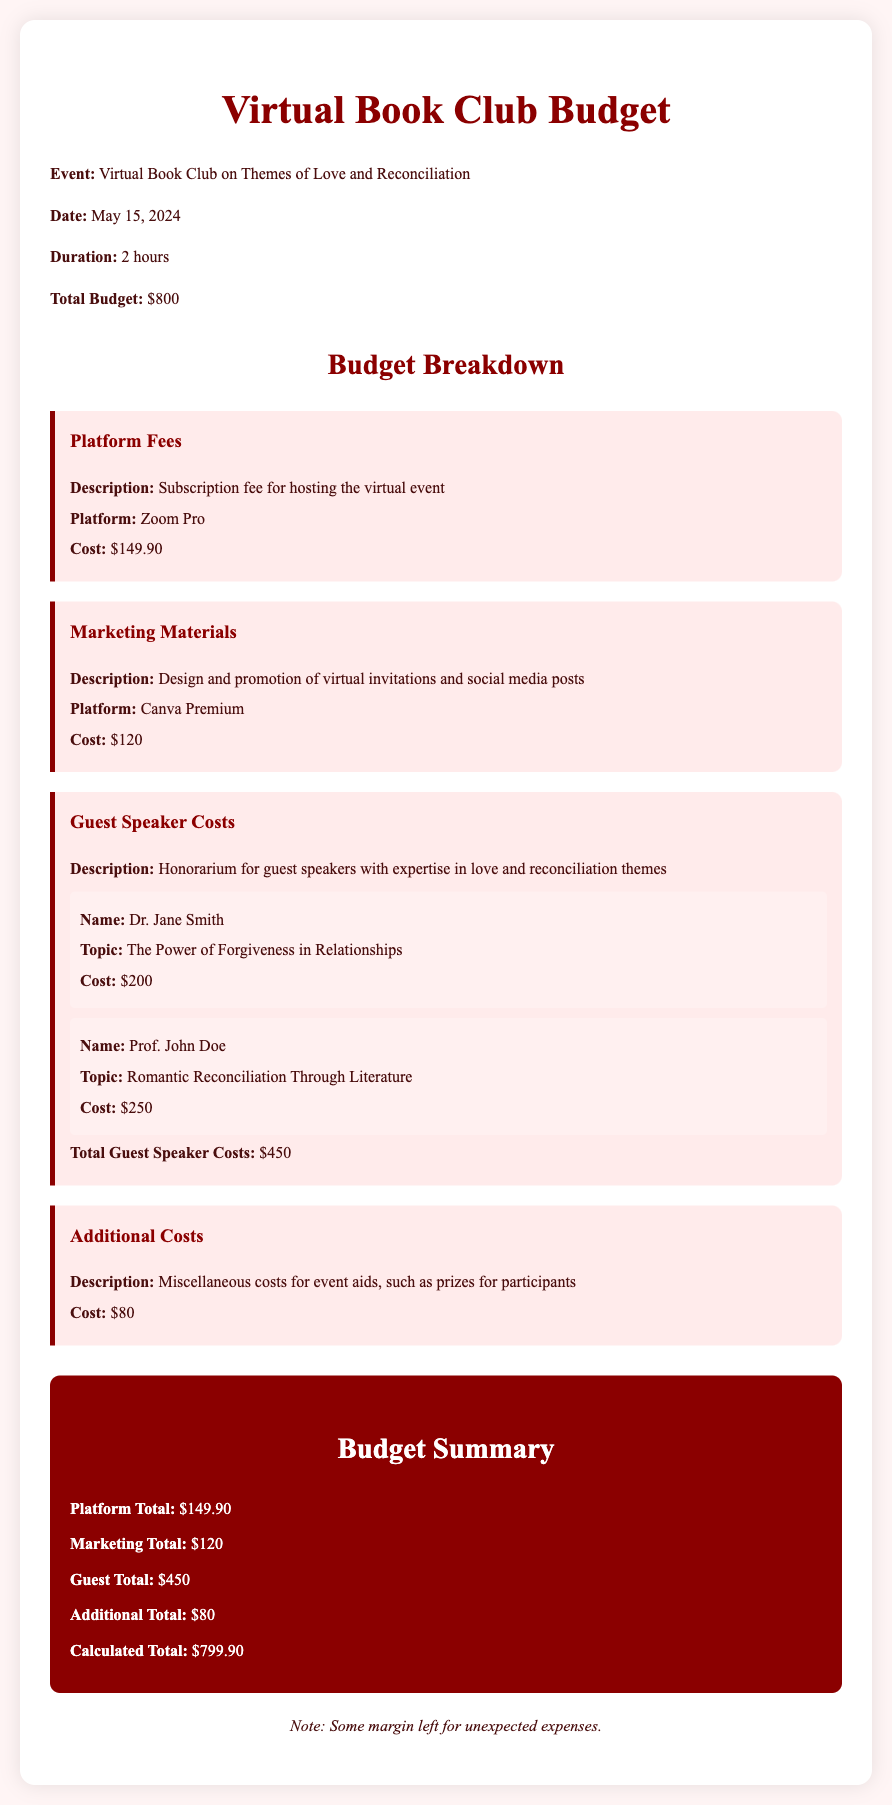what is the date of the event? The date of the event is specified in the document as May 15, 2024.
Answer: May 15, 2024 how much is the total budget? The total budget mentioned in the document is clearly stated as $800.
Answer: $800 what platform is used for hosting the virtual event? The budget document specifies that the platform used for hosting the event is Zoom Pro.
Answer: Zoom Pro who is one of the guest speakers? The document lists Dr. Jane Smith as one of the guest speakers for the event.
Answer: Dr. Jane Smith what is the cost of marketing materials? The document indicates the cost allocated for marketing materials is $120.
Answer: $120 how many guest speakers are included in the budget? The budget details two guest speakers mentioned in the document.
Answer: Two what is the total cost for guest speakers? The total cost for guest speakers is provided as $450 in the budget.
Answer: $450 what is the cost for additional expenses? The document states that the additional costs are $80.
Answer: $80 what is the calculated total for the budget? The calculated total for the budget is noted as $799.90 in the document.
Answer: $799.90 